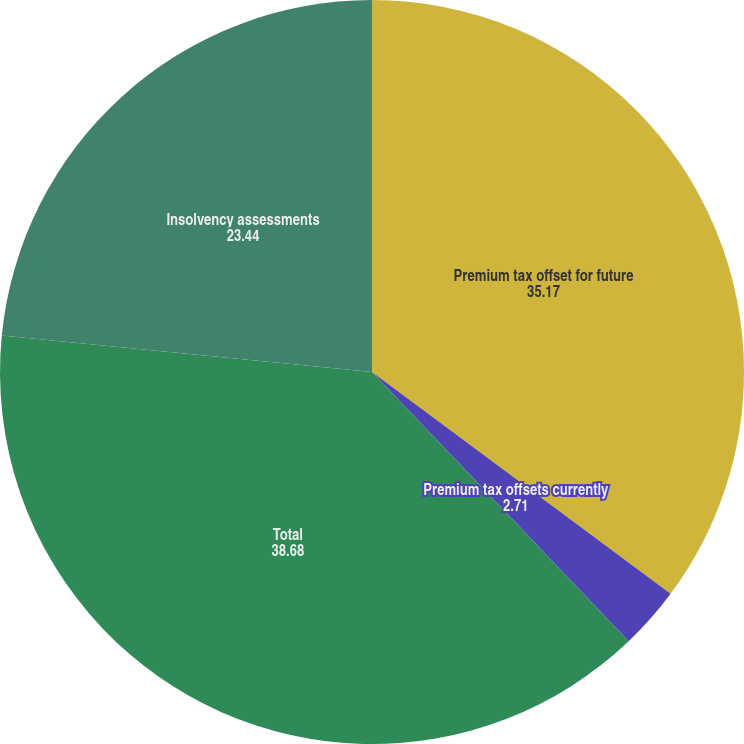<chart> <loc_0><loc_0><loc_500><loc_500><pie_chart><fcel>Premium tax offset for future<fcel>Premium tax offsets currently<fcel>Total<fcel>Insolvency assessments<nl><fcel>35.17%<fcel>2.71%<fcel>38.68%<fcel>23.44%<nl></chart> 